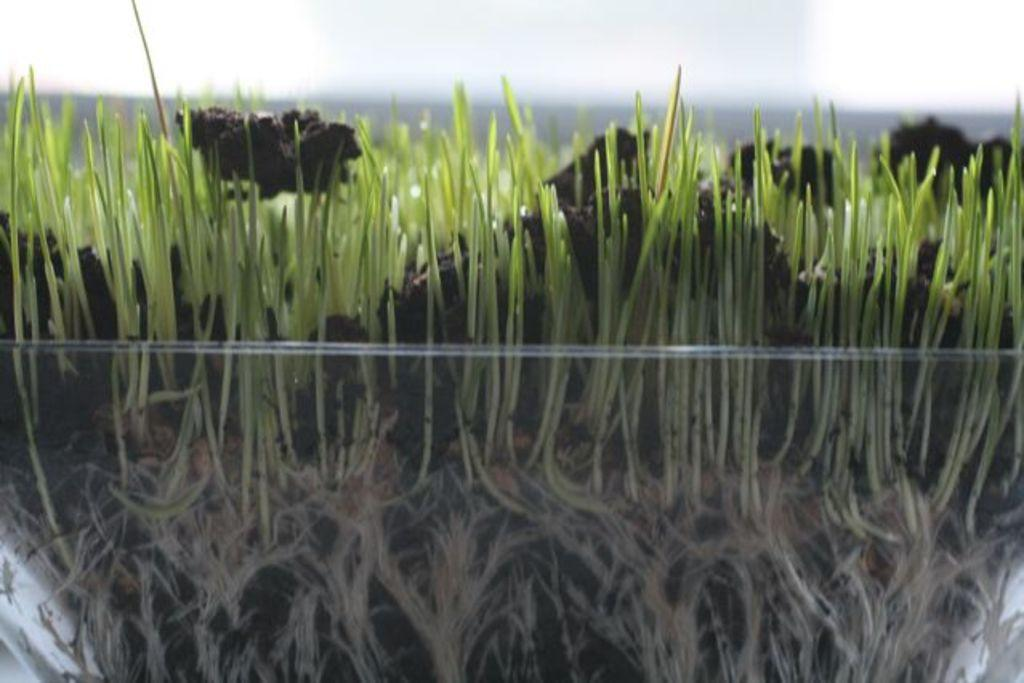What is the main object in the image? There is a glass bowl in the image. What is inside the glass bowl? The glass bowl contains plants. What is the medium in which the plants are growing? The plants are in mud. What can be seen in the background of the image? The sky is visible at the top of the image. What type of camera can be seen in the image? There is no camera present in the image. Is there a fire visible in the image? There is no fire visible in the image. 